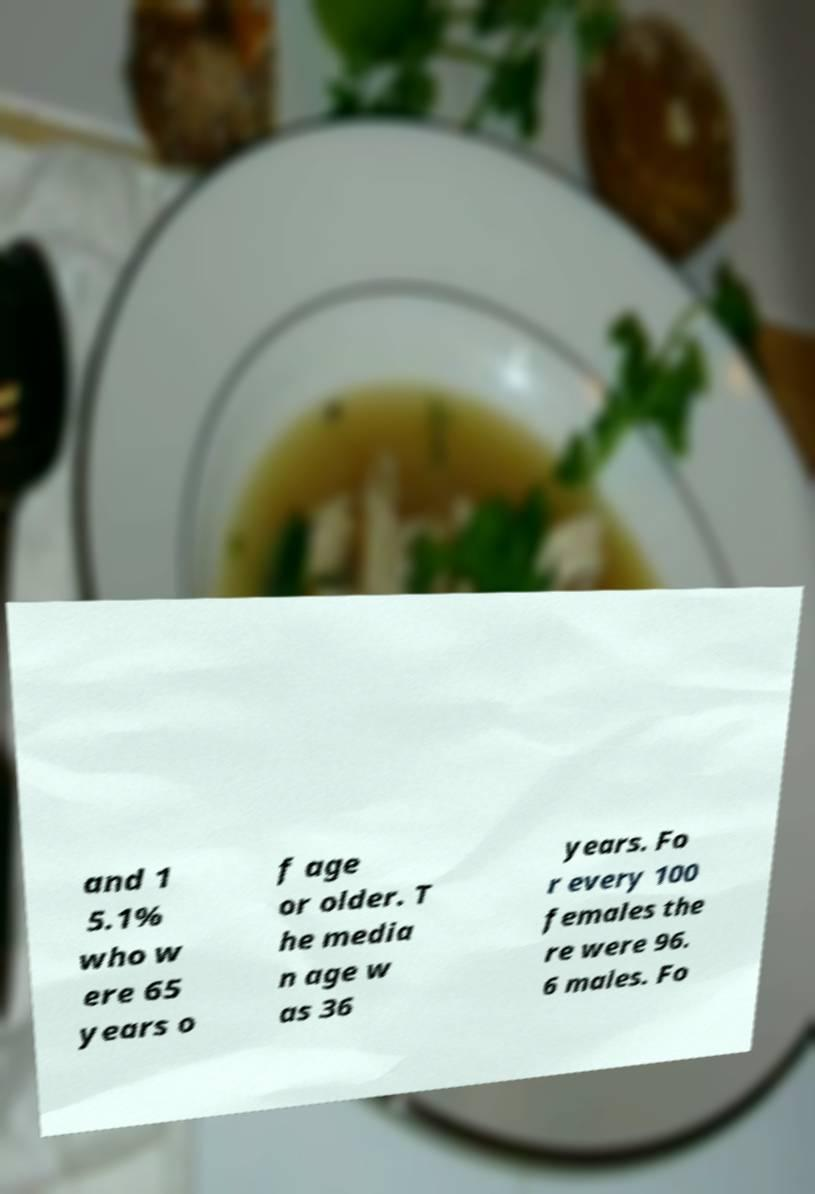Can you read and provide the text displayed in the image?This photo seems to have some interesting text. Can you extract and type it out for me? and 1 5.1% who w ere 65 years o f age or older. T he media n age w as 36 years. Fo r every 100 females the re were 96. 6 males. Fo 